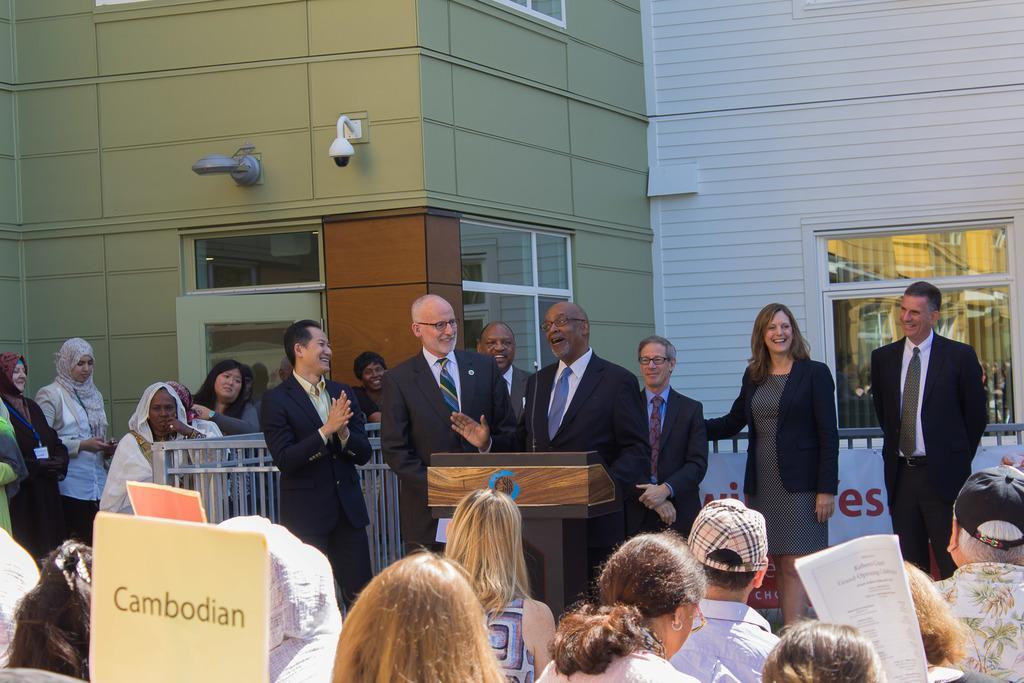Please provide a concise description of this image. In this image, we can see some persons in front of the building. There is a metal fence and podium at the bottom of the image. There is a placard in the bottom left of the image. 